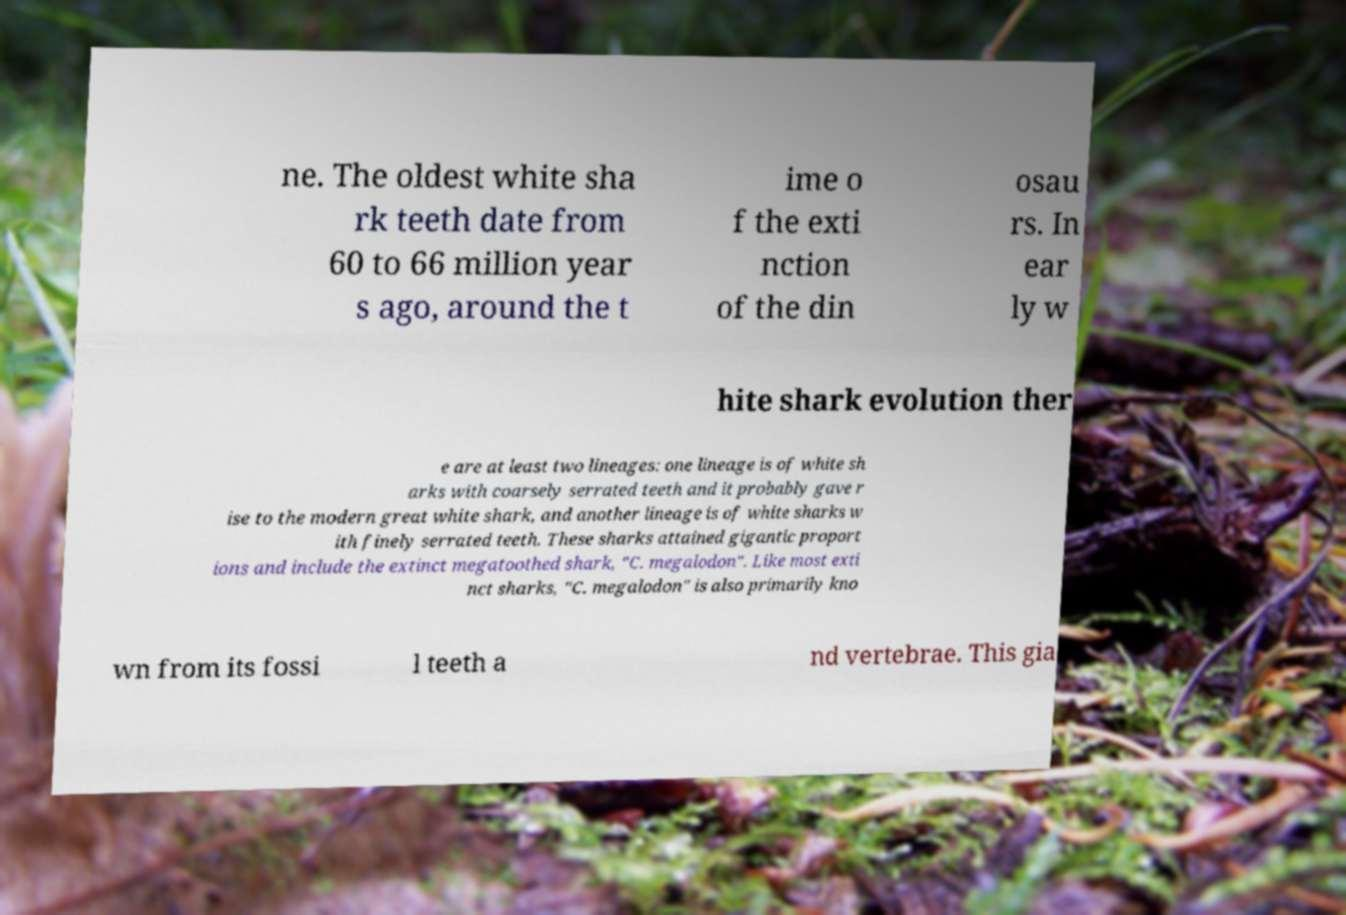Can you accurately transcribe the text from the provided image for me? ne. The oldest white sha rk teeth date from 60 to 66 million year s ago, around the t ime o f the exti nction of the din osau rs. In ear ly w hite shark evolution ther e are at least two lineages: one lineage is of white sh arks with coarsely serrated teeth and it probably gave r ise to the modern great white shark, and another lineage is of white sharks w ith finely serrated teeth. These sharks attained gigantic proport ions and include the extinct megatoothed shark, "C. megalodon". Like most exti nct sharks, "C. megalodon" is also primarily kno wn from its fossi l teeth a nd vertebrae. This gia 